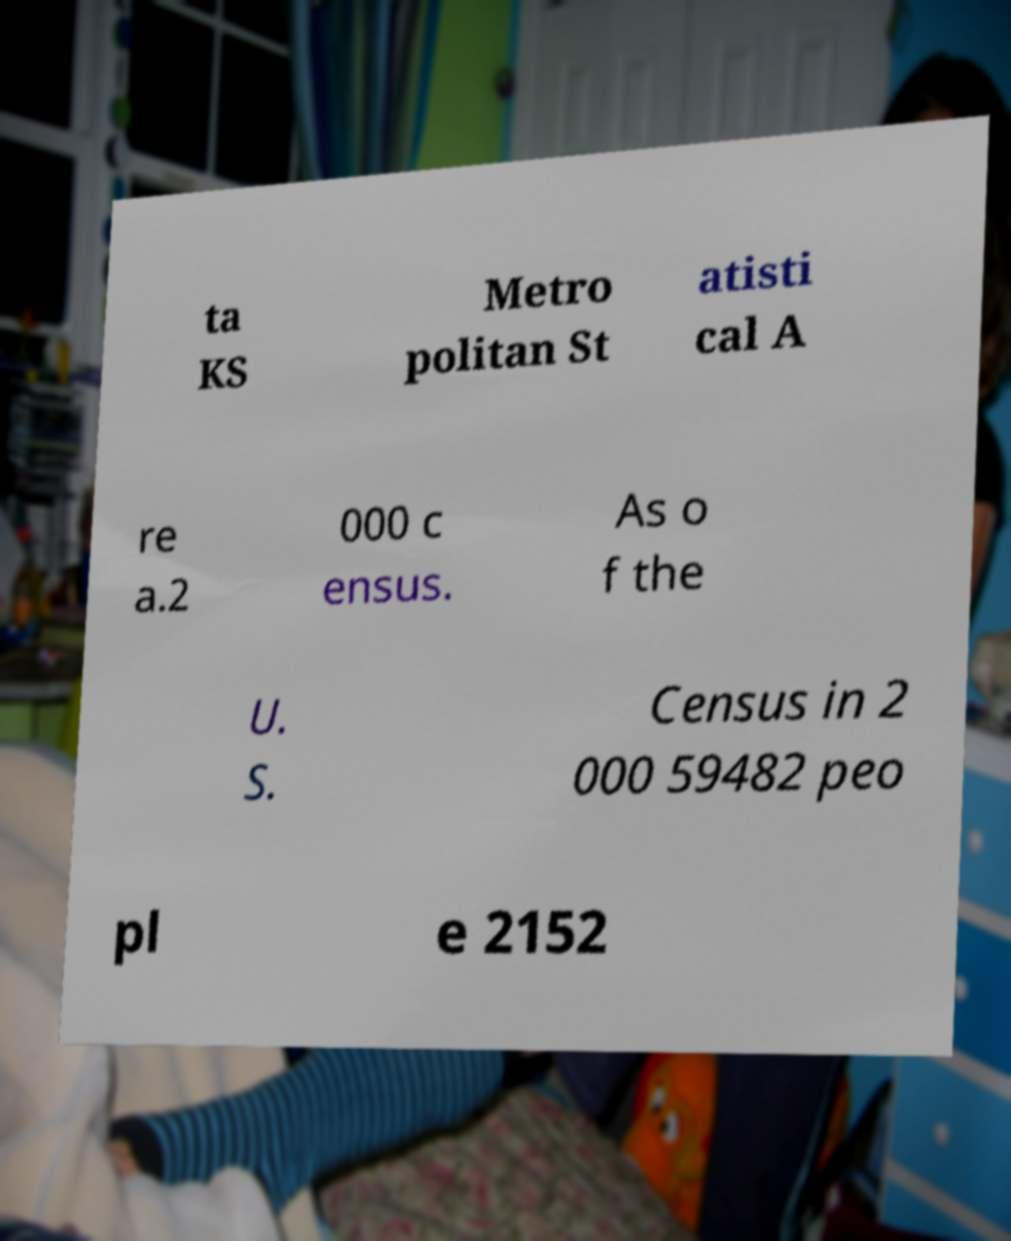Please read and relay the text visible in this image. What does it say? ta KS Metro politan St atisti cal A re a.2 000 c ensus. As o f the U. S. Census in 2 000 59482 peo pl e 2152 